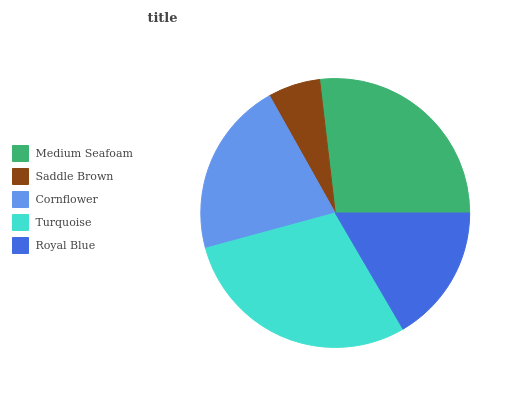Is Saddle Brown the minimum?
Answer yes or no. Yes. Is Turquoise the maximum?
Answer yes or no. Yes. Is Cornflower the minimum?
Answer yes or no. No. Is Cornflower the maximum?
Answer yes or no. No. Is Cornflower greater than Saddle Brown?
Answer yes or no. Yes. Is Saddle Brown less than Cornflower?
Answer yes or no. Yes. Is Saddle Brown greater than Cornflower?
Answer yes or no. No. Is Cornflower less than Saddle Brown?
Answer yes or no. No. Is Cornflower the high median?
Answer yes or no. Yes. Is Cornflower the low median?
Answer yes or no. Yes. Is Saddle Brown the high median?
Answer yes or no. No. Is Saddle Brown the low median?
Answer yes or no. No. 